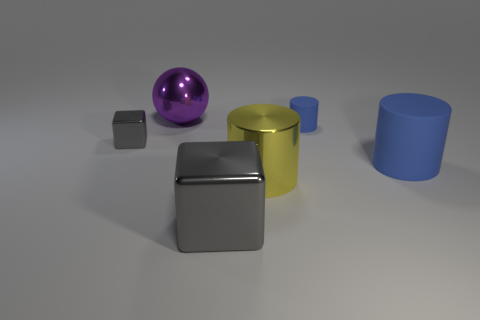Subtract all rubber cylinders. How many cylinders are left? 1 Add 4 big brown metallic balls. How many objects exist? 10 Subtract all gray balls. How many blue cylinders are left? 2 Subtract all balls. How many objects are left? 5 Subtract 2 cylinders. How many cylinders are left? 1 Subtract all yellow cylinders. How many cylinders are left? 2 Subtract all cyan things. Subtract all small metal things. How many objects are left? 5 Add 4 matte objects. How many matte objects are left? 6 Add 5 tiny cylinders. How many tiny cylinders exist? 6 Subtract 0 brown cylinders. How many objects are left? 6 